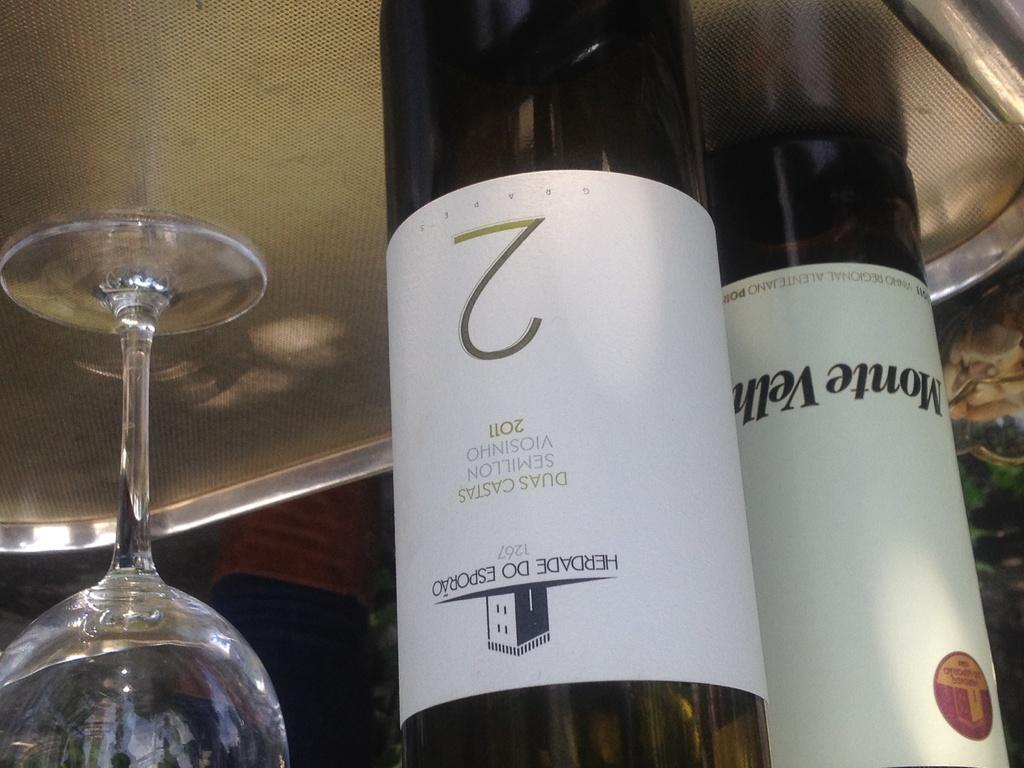<image>
Present a compact description of the photo's key features. The upside down picture shows a bottle of wine with a number 2 written on it. 